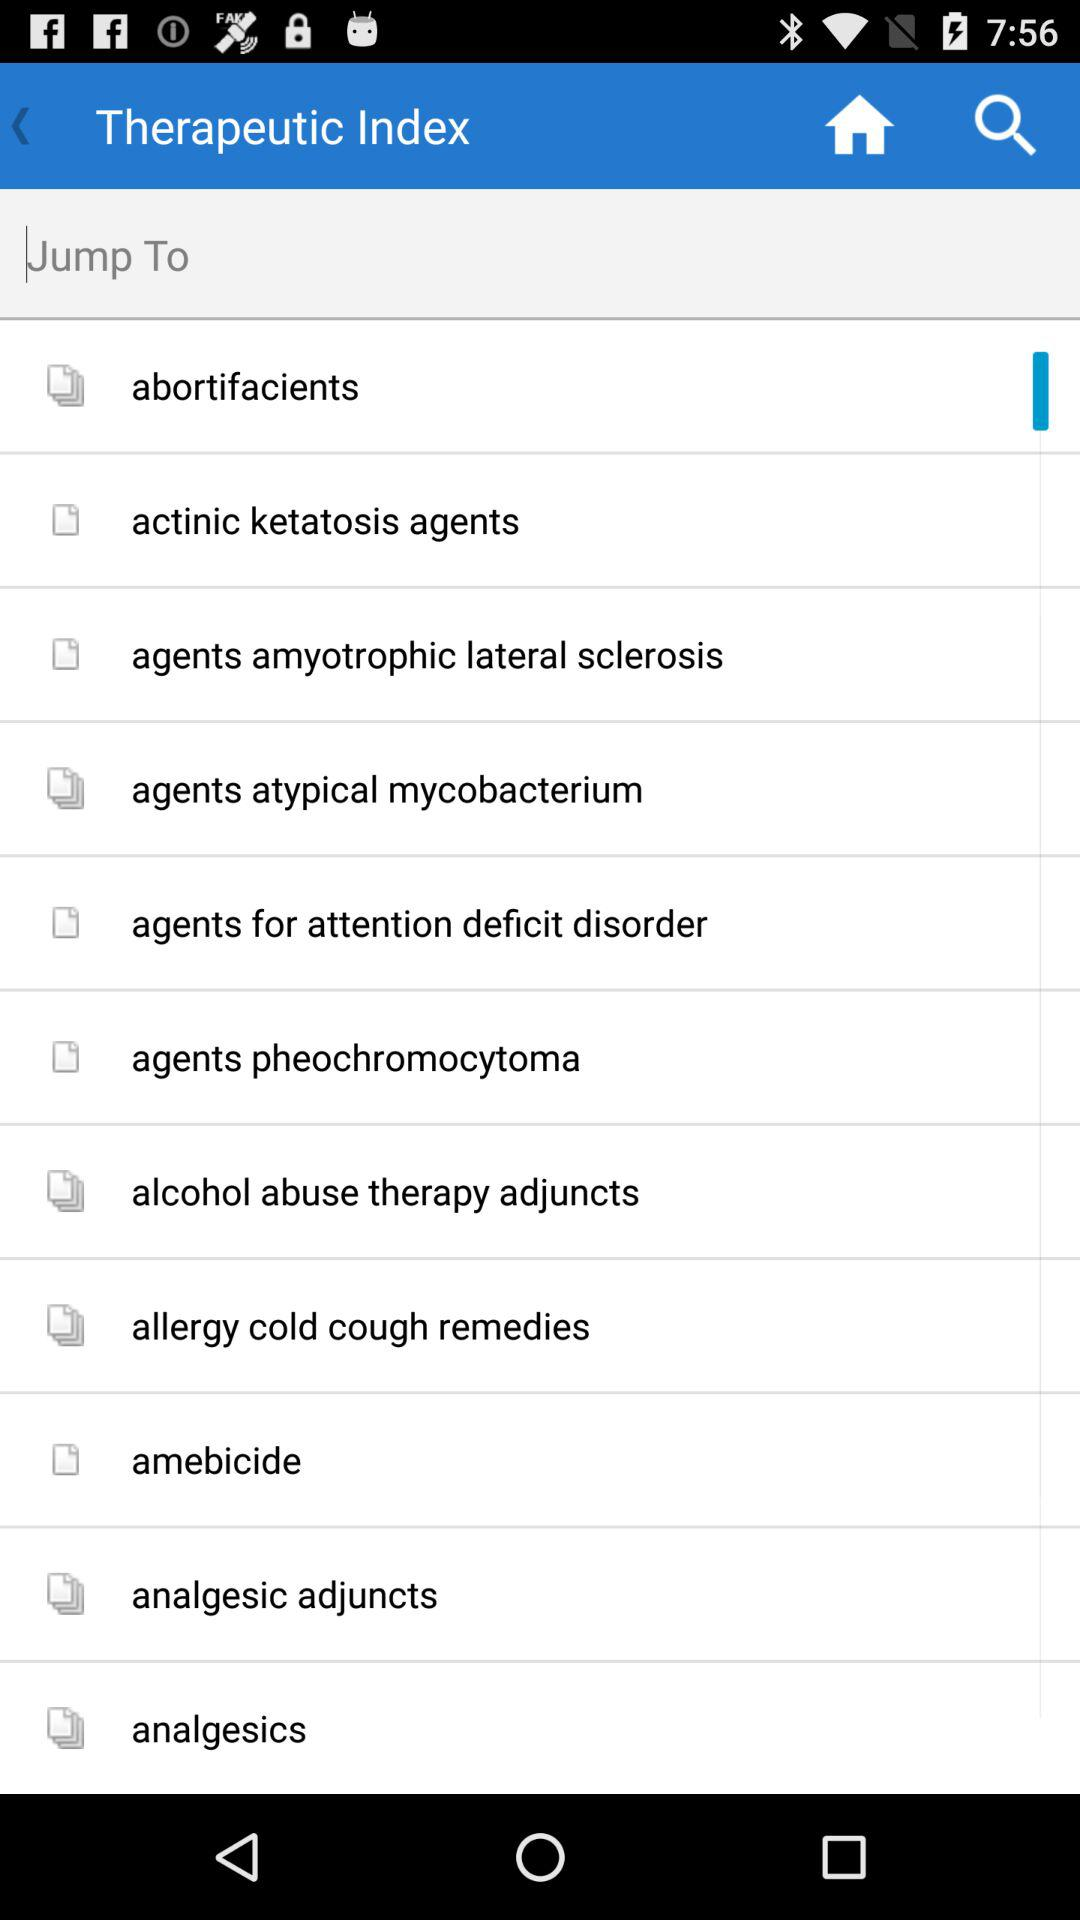What is the name of the application?
When the provided information is insufficient, respond with <no answer>. <no answer> 